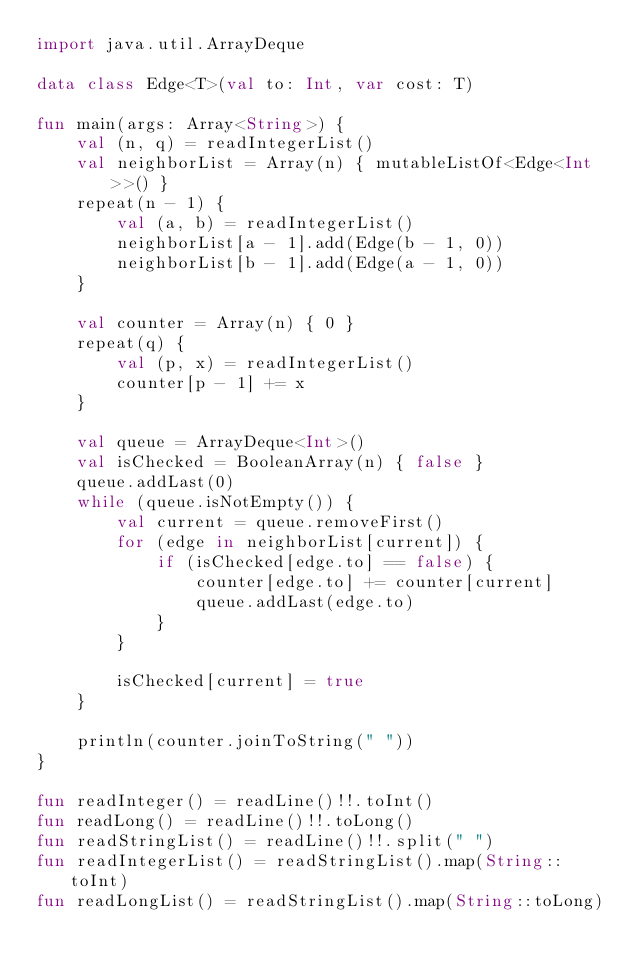<code> <loc_0><loc_0><loc_500><loc_500><_Kotlin_>import java.util.ArrayDeque

data class Edge<T>(val to: Int, var cost: T)

fun main(args: Array<String>) {
    val (n, q) = readIntegerList()
    val neighborList = Array(n) { mutableListOf<Edge<Int>>() }
    repeat(n - 1) {
        val (a, b) = readIntegerList()
        neighborList[a - 1].add(Edge(b - 1, 0))
        neighborList[b - 1].add(Edge(a - 1, 0))
    }

    val counter = Array(n) { 0 }
    repeat(q) {
        val (p, x) = readIntegerList()
        counter[p - 1] += x
    }

    val queue = ArrayDeque<Int>()
    val isChecked = BooleanArray(n) { false }
    queue.addLast(0)
    while (queue.isNotEmpty()) {
        val current = queue.removeFirst()
        for (edge in neighborList[current]) {
            if (isChecked[edge.to] == false) {
                counter[edge.to] += counter[current]
                queue.addLast(edge.to)
            }
        }

        isChecked[current] = true
    }

    println(counter.joinToString(" "))
}

fun readInteger() = readLine()!!.toInt()
fun readLong() = readLine()!!.toLong()
fun readStringList() = readLine()!!.split(" ")
fun readIntegerList() = readStringList().map(String::toInt)
fun readLongList() = readStringList().map(String::toLong)
</code> 